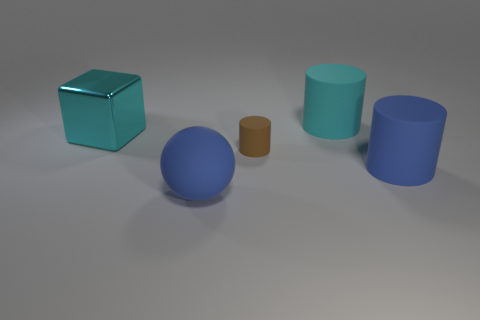Are there any large cyan cylinders behind the large ball?
Offer a terse response. Yes. Are there any other things that have the same color as the small cylinder?
Offer a very short reply. No. How many balls are either big blue matte things or small things?
Offer a terse response. 1. How many matte cylinders are behind the metallic block and in front of the brown object?
Offer a very short reply. 0. Is the number of cyan matte objects to the left of the cyan matte cylinder the same as the number of metallic blocks that are behind the brown thing?
Provide a short and direct response. No. Is the shape of the large blue matte object that is on the right side of the small brown rubber cylinder the same as  the small matte thing?
Offer a very short reply. Yes. There is a blue matte thing behind the big rubber object that is on the left side of the cylinder behind the cyan shiny object; what is its shape?
Provide a short and direct response. Cylinder. What material is the big object that is both behind the tiny brown matte cylinder and in front of the cyan cylinder?
Offer a very short reply. Metal. Are there fewer large green cubes than tiny things?
Keep it short and to the point. Yes. Does the tiny brown rubber object have the same shape as the object that is on the right side of the cyan matte cylinder?
Provide a succinct answer. Yes. 